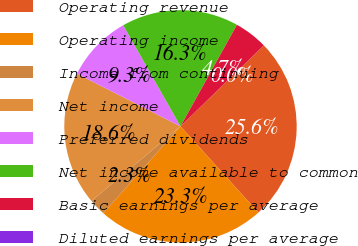<chart> <loc_0><loc_0><loc_500><loc_500><pie_chart><fcel>Operating revenue<fcel>Operating income<fcel>Income from continuing<fcel>Net income<fcel>Preferred dividends<fcel>Net income available to common<fcel>Basic earnings per average<fcel>Diluted earnings per average<nl><fcel>25.58%<fcel>23.25%<fcel>2.33%<fcel>18.6%<fcel>9.3%<fcel>16.28%<fcel>4.65%<fcel>0.0%<nl></chart> 